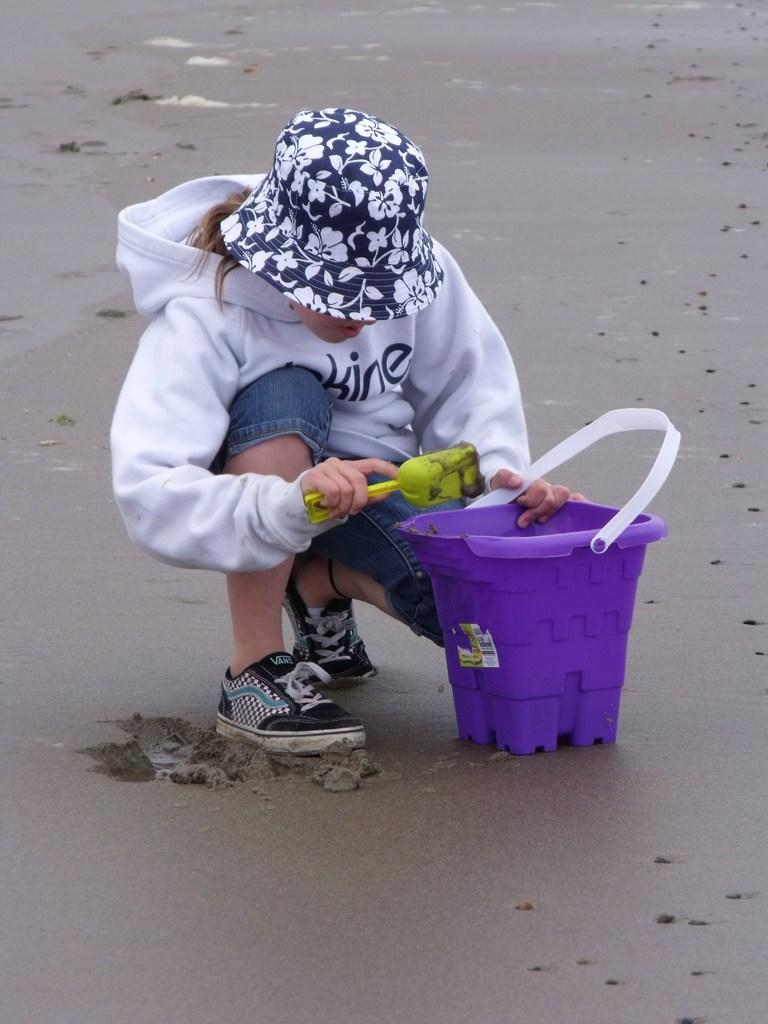Who is the main subject in the image? There is a girl in the image. What position is the girl in? The girl is sitting in a squat position. What is the girl holding in the image? The girl is holding a bucket and another object. What is the girl wearing on her head? The girl is wearing a hat. What type of surface is visible in the image? There is sand visible in the image. What grade did the girl receive for her picture in the image? There is no picture or mention of a grade in the image. The girl is holding a bucket and another object, and she is sitting in a squat position on a sandy surface while wearing a hat? 